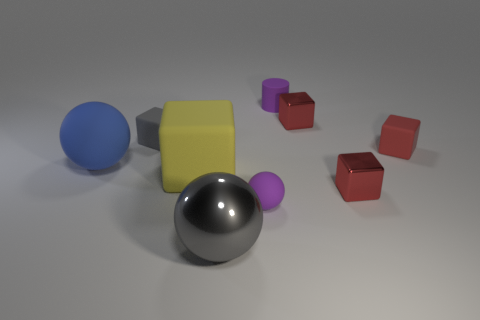Is the number of gray cubes in front of the large gray ball greater than the number of yellow blocks?
Provide a short and direct response. No. Are there any yellow blocks right of the small matte sphere?
Your response must be concise. No. Is the size of the red matte block the same as the gray matte block?
Your answer should be compact. Yes. What size is the gray object that is the same shape as the large yellow thing?
Offer a terse response. Small. What material is the purple ball that is in front of the blue matte object that is to the left of the gray ball made of?
Offer a terse response. Rubber. Does the blue thing have the same shape as the gray metallic thing?
Offer a terse response. Yes. How many things are in front of the small matte sphere and on the right side of the tiny matte cylinder?
Your response must be concise. 0. Are there the same number of purple matte things behind the red matte thing and small cylinders that are to the left of the big gray metallic object?
Offer a very short reply. No. There is a sphere in front of the purple rubber ball; is its size the same as the purple rubber object that is in front of the purple matte cylinder?
Offer a terse response. No. There is a ball that is both on the right side of the large yellow rubber object and behind the large gray metal sphere; what material is it?
Your answer should be very brief. Rubber. 